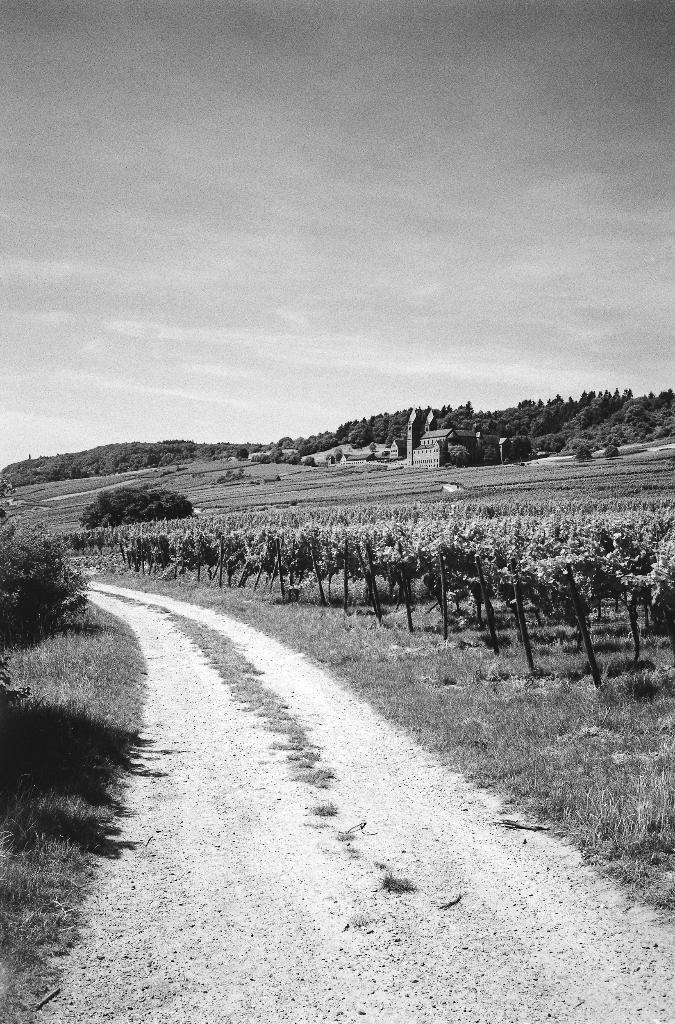What is the main feature of the image? There is a road in the picture. What can be seen beside the road? There are trees beside the road. What type of vegetation is present in the image? There is grass in the picture. What type of structures can be seen in the image? There are buildings in the picture. What type of furniture can be seen in the image? There is no furniture present in the image. How does the growth of the trees affect the road in the image? The image does not show any growth of trees affecting the road; the trees are simply beside the road. 